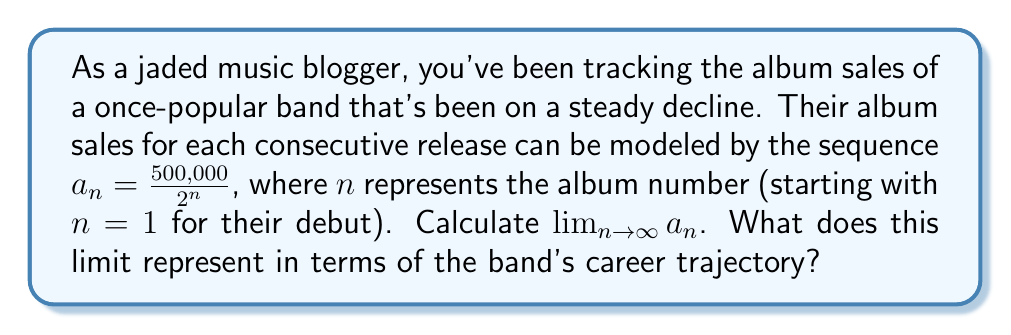Teach me how to tackle this problem. To solve this problem, let's break it down step-by-step:

1) We're given the sequence $a_n = \frac{500,000}{2^n}$

2) To find the limit as $n$ approaches infinity, we need to evaluate:

   $$\lim_{n \to \infty} \frac{500,000}{2^n}$$

3) We can factor out the constant in the numerator:

   $$500,000 \cdot \lim_{n \to \infty} \frac{1}{2^n}$$

4) Now, let's focus on $\lim_{n \to \infty} \frac{1}{2^n}$:
   - As $n$ gets larger, $2^n$ grows exponentially
   - $\frac{1}{2^n}$ becomes increasingly small

5) In fact, $\lim_{n \to \infty} \frac{1}{2^n} = 0$

6) Therefore:

   $$500,000 \cdot \lim_{n \to \infty} \frac{1}{2^n} = 500,000 \cdot 0 = 0$$

7) Interpreting this result:
   - The limit being 0 means that as the band releases more albums, their sales approach zero
   - This represents a complete loss of their fan base and commercial viability

This mathematical model paints a bleak picture of the band's future, reflecting the cynical view of a jaded music blogger. However, it's worth noting that real-world album sales don't typically follow such a strict mathematical progression, leaving room for potential comeback stories or cult followings.
Answer: $\lim_{n \to \infty} a_n = 0$ 